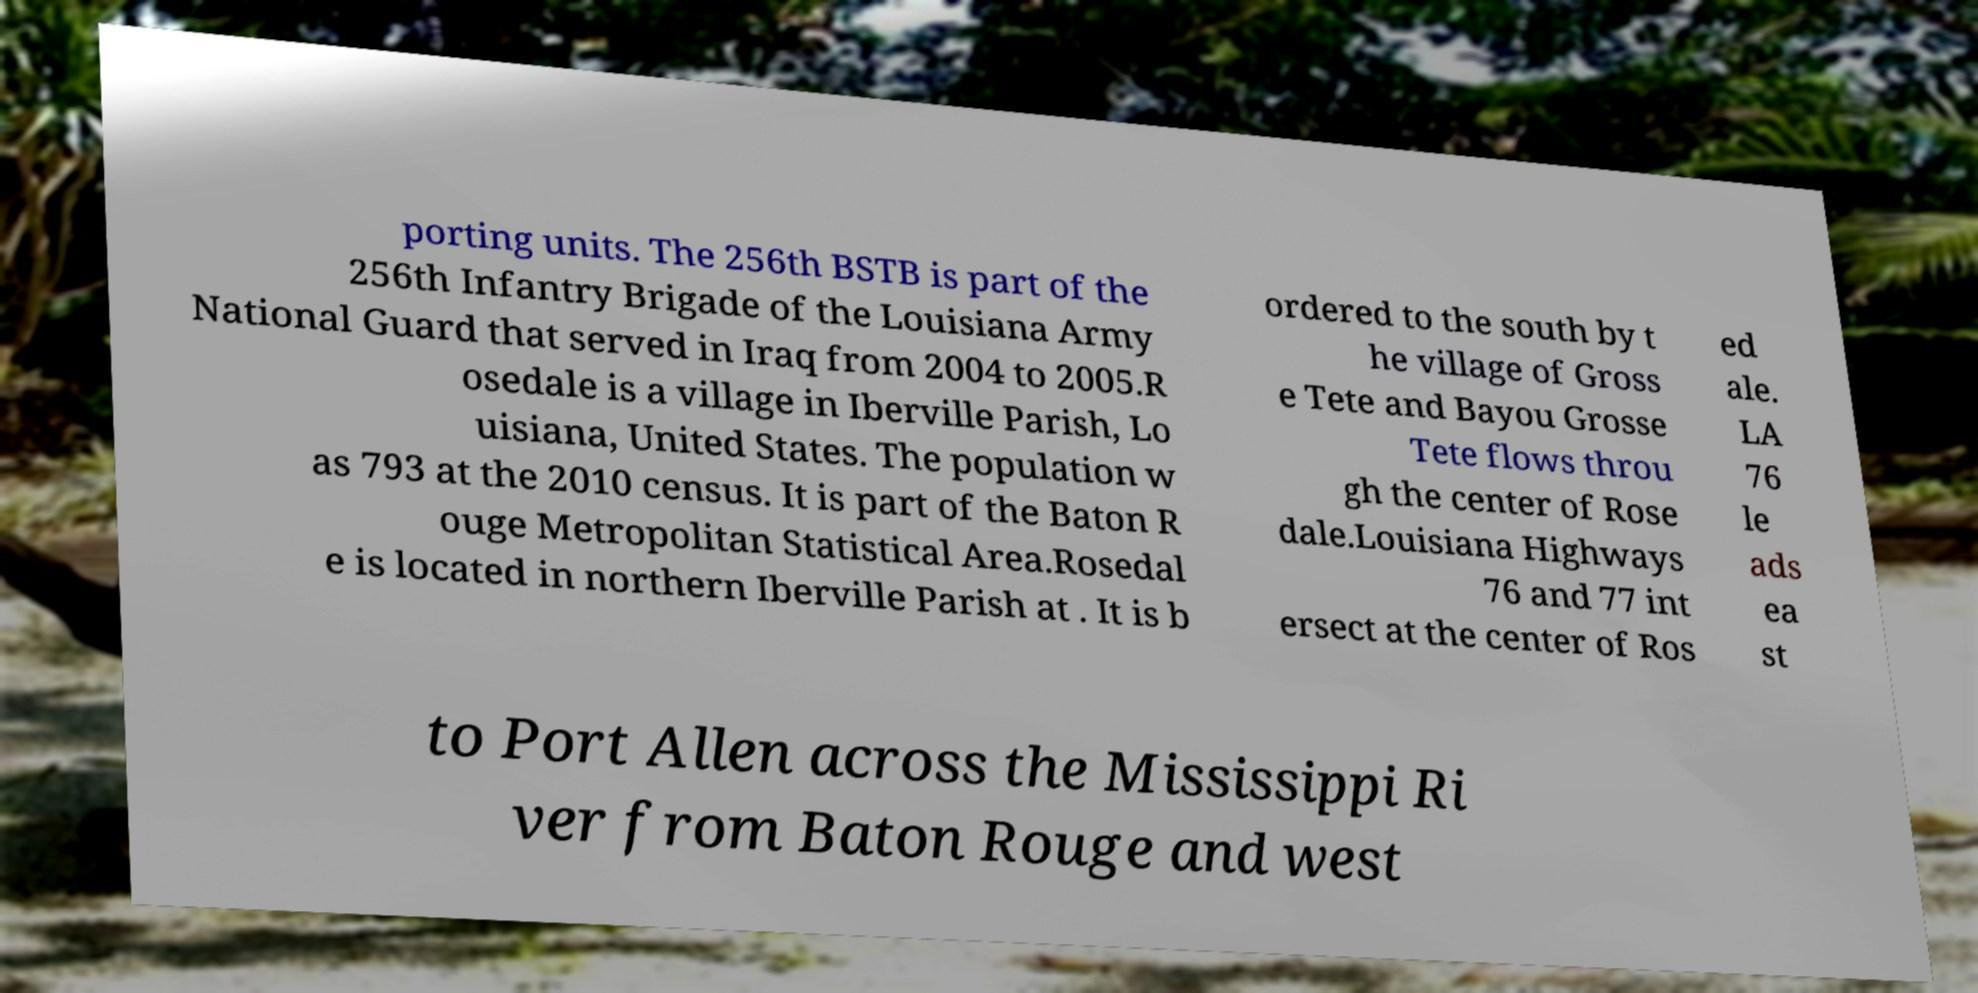Can you read and provide the text displayed in the image?This photo seems to have some interesting text. Can you extract and type it out for me? porting units. The 256th BSTB is part of the 256th Infantry Brigade of the Louisiana Army National Guard that served in Iraq from 2004 to 2005.R osedale is a village in Iberville Parish, Lo uisiana, United States. The population w as 793 at the 2010 census. It is part of the Baton R ouge Metropolitan Statistical Area.Rosedal e is located in northern Iberville Parish at . It is b ordered to the south by t he village of Gross e Tete and Bayou Grosse Tete flows throu gh the center of Rose dale.Louisiana Highways 76 and 77 int ersect at the center of Ros ed ale. LA 76 le ads ea st to Port Allen across the Mississippi Ri ver from Baton Rouge and west 